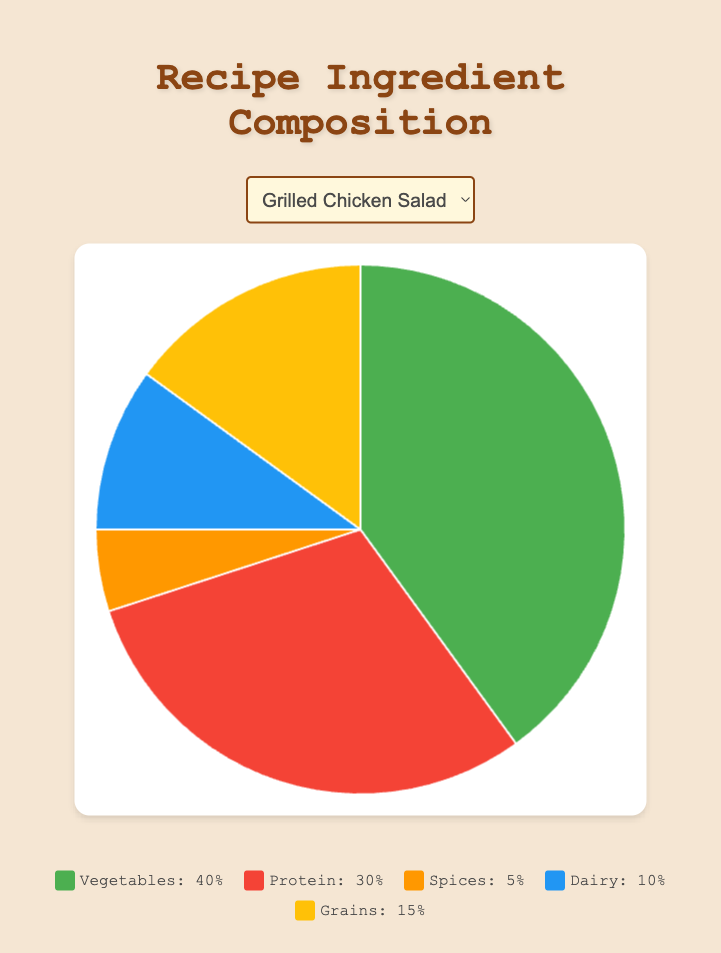Which recipe has the highest percentage of Vegetables? Observe the pie charts for each recipe. The "Vegetable Stir Fry" portion has the Vegetables section taking up a large portion relative to the others at 60%.
Answer: Vegetable Stir Fry Which recipe has the least percentage of Spices? Compare the Spice sections in the pie charts for each recipe. The "Grilled Chicken Salad" has the least at 5%.
Answer: Grilled Chicken Salad How much greater is the percentage of Dairy in Spaghetti Carbonara compared to Lentil Soup? Spaghetti Carbonara has 30% Dairy, while Lentil Soup has 5%. The difference is 30% - 5% = 25%.
Answer: 25% Which recipes have the same percentage of Grains? Examine the Grains portion in each pie chart. "Vegetable Stir Fry", "Beef Tacos" and "Grilled Chicken Salad" all have 15% Grains.
Answer: Vegetable Stir Fry, Beef Tacos, Grilled Chicken Salad What is the combined percentage of Protein and Grains in Quinoa Salad? For Quinoa Salad, Protein is 15% and Grains is 35%. Sum these up: 15% + 35% = 50%.
Answer: 50% Which ingredient has the highest percentage in Fish and Chips? Look at the proportions in the Fish and Chips pie chart. Protein has the largest section at 35%.
Answer: Protein Is the percentage of Spices in Paneer Tikka Masala greater than the percentage of Protein in Vegetable Stir Fry? Paneer Tikka Masala has 20% Spices and Vegetable Stir Fry has 15% Protein. 20% is greater than 15%.
Answer: Yes Compare the Dairy percentage in Paneer Tikka Masala and Fish and Chips. Which has more? Paneer Tikka Masala has 15% Dairy, while Fish and Chips has 5%. Paneer Tikka Masala has more.
Answer: Paneer Tikka Masala In Beef Tacos, which ingredient is the second most prevalent? In Beef Tacos, Protein is 40%, Vegetables is 20%, Spices is 15%, Dairy is 10%, and Grains is 15%. The second most prevalent is 20% Vegetables.
Answer: Vegetables 